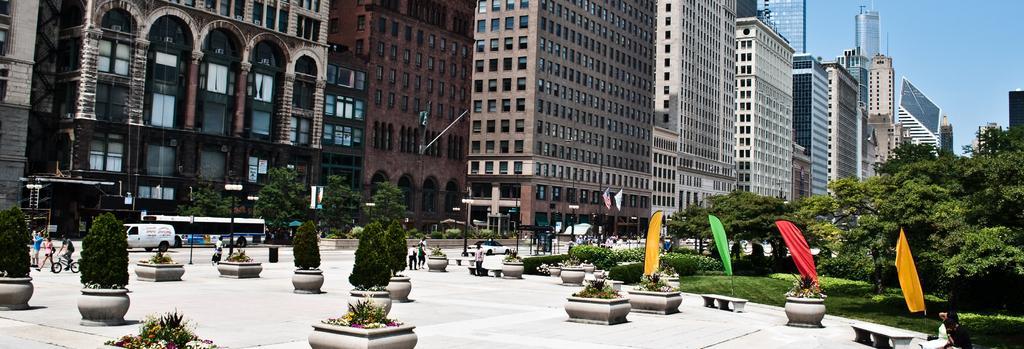In one or two sentences, can you explain what this image depicts? On the right side there are many trees and plants. And there are many benches and pots with plants. Also there are few people. One person is riding a cycle. And there are benches. In the back there are many buildings with windows and arches. Also there are trees and light poles. On the left side there is sky. 